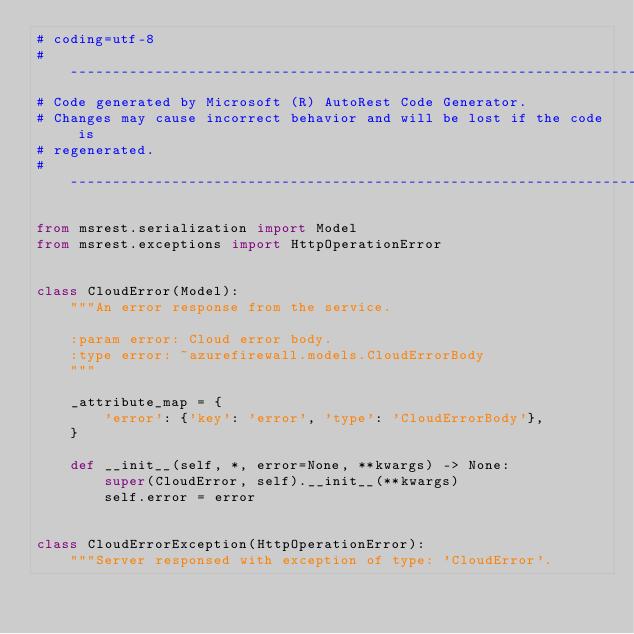<code> <loc_0><loc_0><loc_500><loc_500><_Python_># coding=utf-8
# --------------------------------------------------------------------------
# Code generated by Microsoft (R) AutoRest Code Generator.
# Changes may cause incorrect behavior and will be lost if the code is
# regenerated.
# --------------------------------------------------------------------------

from msrest.serialization import Model
from msrest.exceptions import HttpOperationError


class CloudError(Model):
    """An error response from the service.

    :param error: Cloud error body.
    :type error: ~azurefirewall.models.CloudErrorBody
    """

    _attribute_map = {
        'error': {'key': 'error', 'type': 'CloudErrorBody'},
    }

    def __init__(self, *, error=None, **kwargs) -> None:
        super(CloudError, self).__init__(**kwargs)
        self.error = error


class CloudErrorException(HttpOperationError):
    """Server responsed with exception of type: 'CloudError'.
</code> 